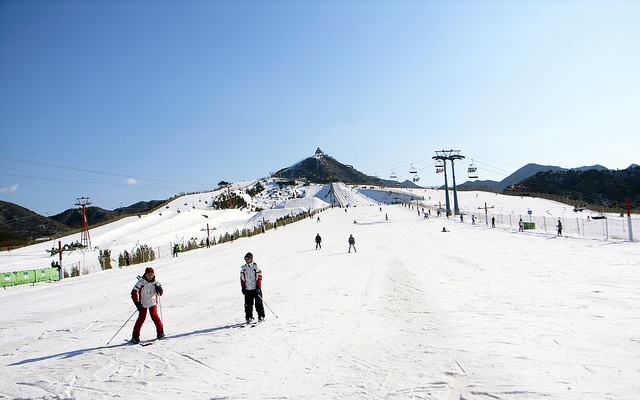Describe the objects in this image and their specific colors. I can see people in blue, lightgray, gray, darkgray, and darkgreen tones, people in blue, black, darkgray, white, and maroon tones, people in blue, black, darkgray, gray, and white tones, people in blue, white, gray, black, and maroon tones, and people in blue, black, gray, and darkgray tones in this image. 